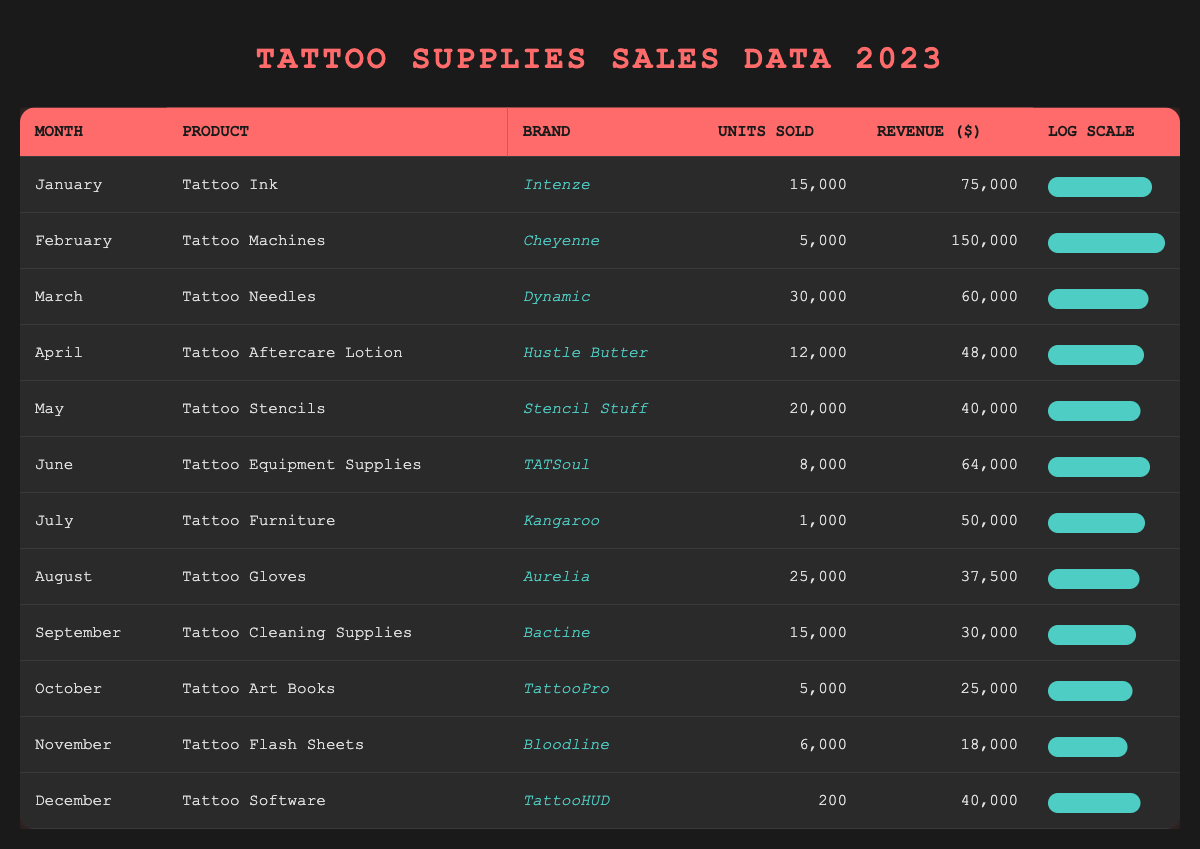What's the product with the highest revenue in February? The revenue for February is listed next to the product "Tattoo Machines" by the brand "Cheyenne," which is 150,000.
Answer: Tattoo Machines What is the total number of units sold for all products in March? In March, the total units sold is given by the entry for "Tattoo Needles," which is 30,000. Adding this as it is the only product for that month, the total units sold for March is 30,000.
Answer: 30,000 Which brand of tattoo supplies had the least units sold in July? By checking the July entry, "Tattoo Furniture" by the brand "Kangaroo" sold only 1,000 units, making it the least sold product for that month.
Answer: Kangaroo What is the average revenue of tattoo supplies sold from January to December? First, sum the revenues from each month: 75,000 + 150,000 + 60,000 + 48,000 + 40,000 + 64,000 + 50,000 + 37,500 + 30,000 + 25,000 + 18,000 + 40,000 =  111,500. With 12 months, the average revenue is calculated as  726,500 / 12 = 60,541.67, rounded to 60,542.
Answer: 60,542 Did any product sell more than 25,000 units? By examining the units sold, "Tattoo Needles" at 30,000 and "Tattoo Gloves" at 25,000 both exceed 25,000, so the statement is true.
Answer: Yes Which month saw the highest number of units sold overall? The maximum units sold are from "Tattoo Needles" in March, totaling 30,000. Checking the individual monthly units confirms March has the highest units sold.
Answer: March What percentage of the total revenue does "Tattoo Aftercare Lotion" represent in April? The revenue for April is 48,000, while the total revenue from January to December is 726,500. The percentage is (48,000 / 726,500) * 100, which calculates approximately to 6.6%.
Answer: 6.6% Is "Tattoo Software" the least sold product throughout the year? The entry for "Tattoo Software" shows only 200 units sold, which is less than several other products, specifically "Tattoo Furniture" at 1,000 units, hence it is not the least sold.
Answer: No 